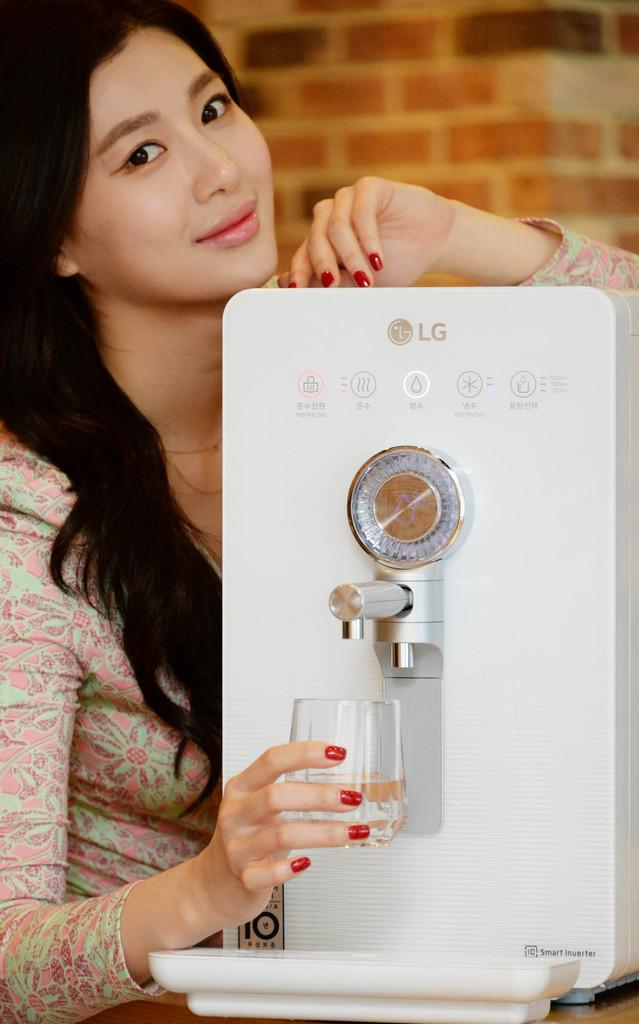<image>
Render a clear and concise summary of the photo. A woman is getting a glass of water from an LG water dispenser. 